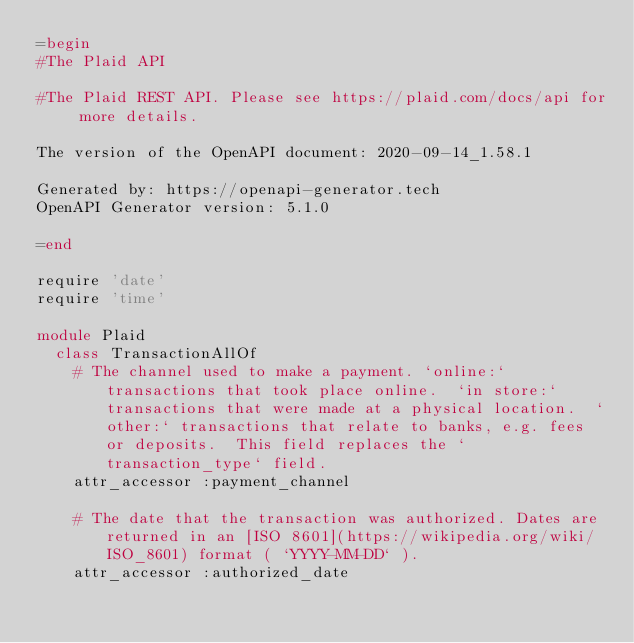Convert code to text. <code><loc_0><loc_0><loc_500><loc_500><_Ruby_>=begin
#The Plaid API

#The Plaid REST API. Please see https://plaid.com/docs/api for more details.

The version of the OpenAPI document: 2020-09-14_1.58.1

Generated by: https://openapi-generator.tech
OpenAPI Generator version: 5.1.0

=end

require 'date'
require 'time'

module Plaid
  class TransactionAllOf
    # The channel used to make a payment. `online:` transactions that took place online.  `in store:` transactions that were made at a physical location.  `other:` transactions that relate to banks, e.g. fees or deposits.  This field replaces the `transaction_type` field. 
    attr_accessor :payment_channel

    # The date that the transaction was authorized. Dates are returned in an [ISO 8601](https://wikipedia.org/wiki/ISO_8601) format ( `YYYY-MM-DD` ).
    attr_accessor :authorized_date
</code> 